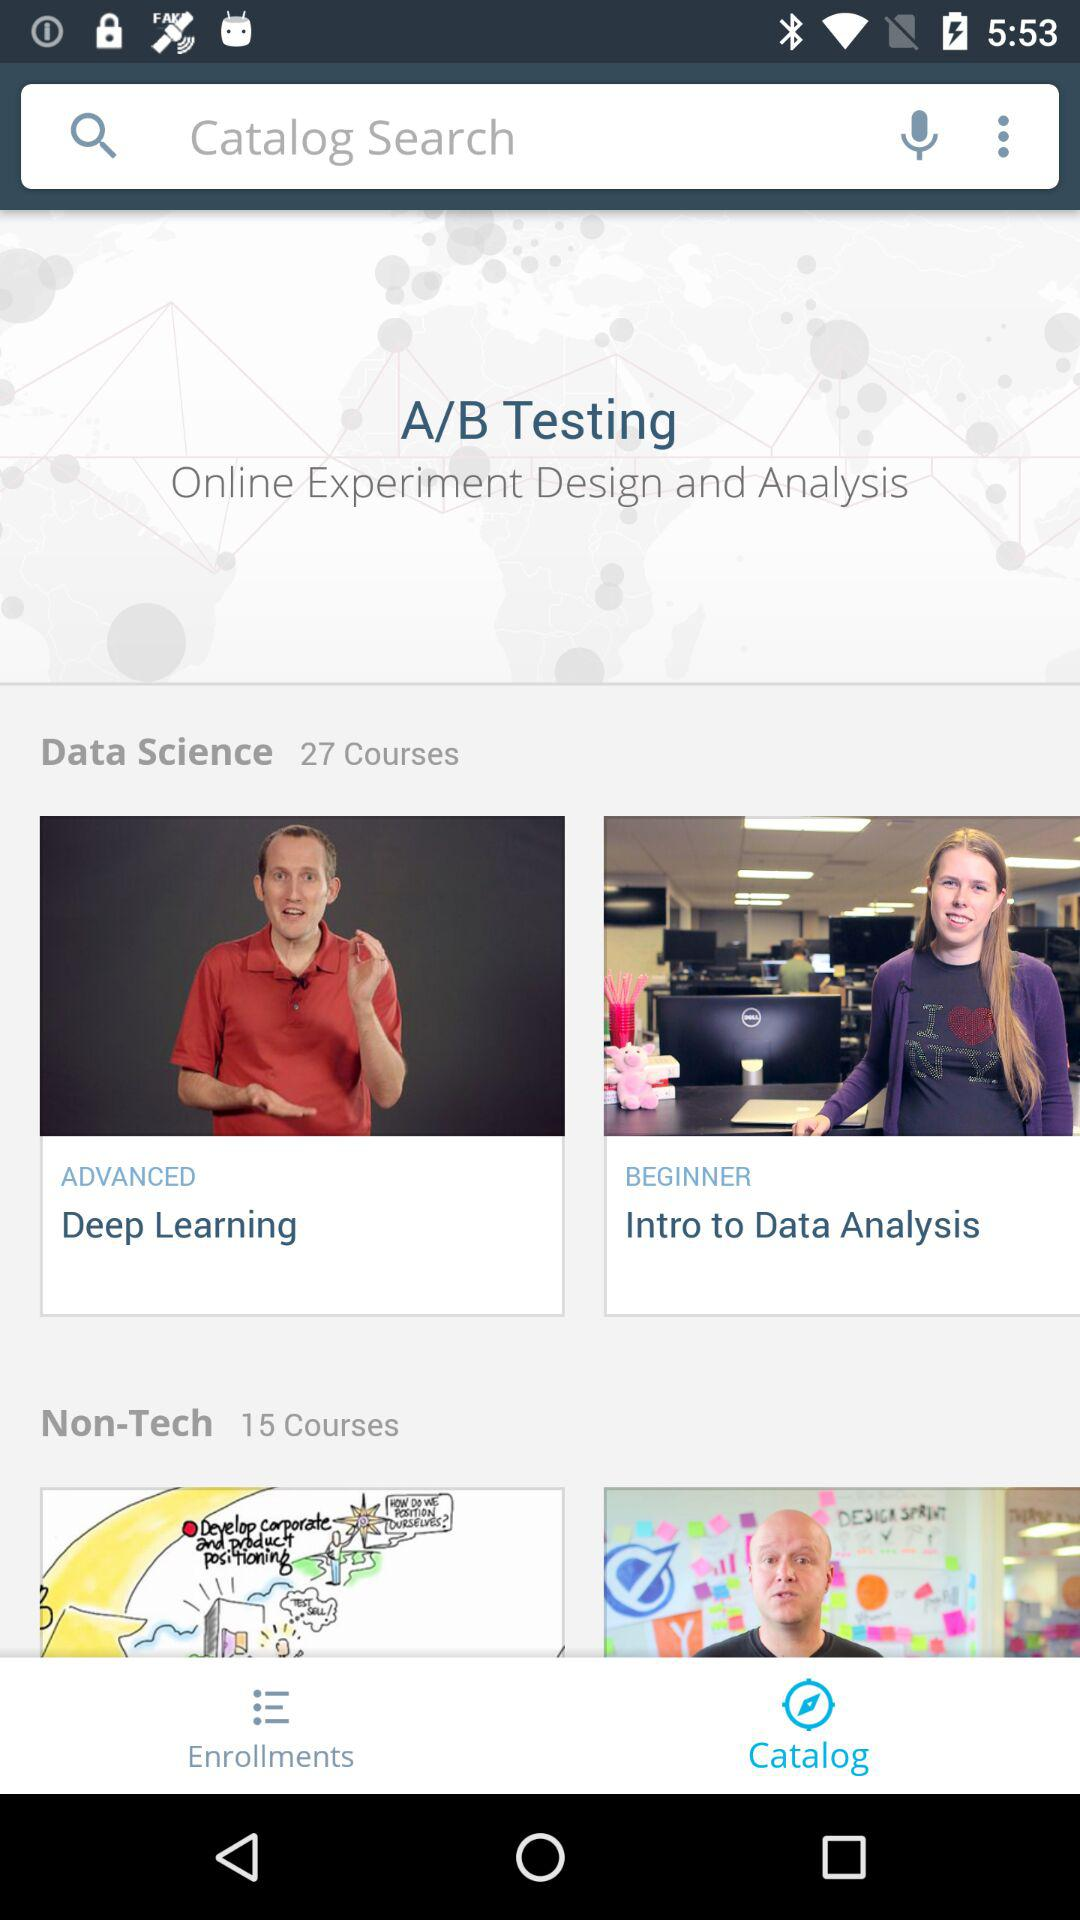What is the name of the beginner data science course? The name of the beginner data science course is "Intro to Data Analysis". 